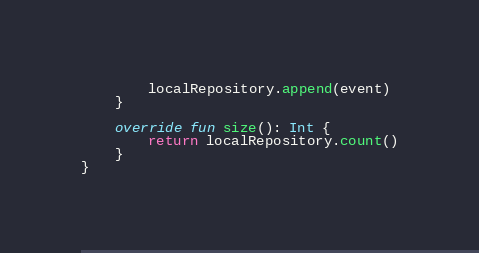<code> <loc_0><loc_0><loc_500><loc_500><_Kotlin_>        localRepository.append(event)
    }

    override fun size(): Int {
        return localRepository.count()
    }
}
</code> 